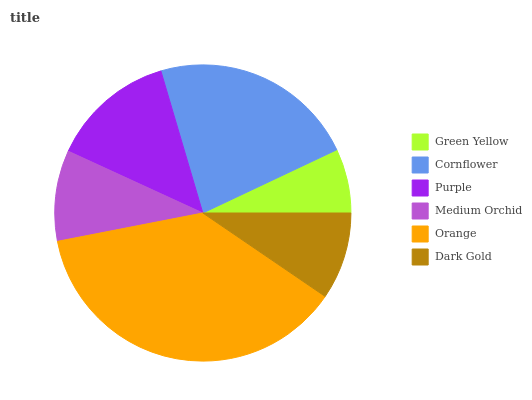Is Green Yellow the minimum?
Answer yes or no. Yes. Is Orange the maximum?
Answer yes or no. Yes. Is Cornflower the minimum?
Answer yes or no. No. Is Cornflower the maximum?
Answer yes or no. No. Is Cornflower greater than Green Yellow?
Answer yes or no. Yes. Is Green Yellow less than Cornflower?
Answer yes or no. Yes. Is Green Yellow greater than Cornflower?
Answer yes or no. No. Is Cornflower less than Green Yellow?
Answer yes or no. No. Is Purple the high median?
Answer yes or no. Yes. Is Medium Orchid the low median?
Answer yes or no. Yes. Is Cornflower the high median?
Answer yes or no. No. Is Cornflower the low median?
Answer yes or no. No. 